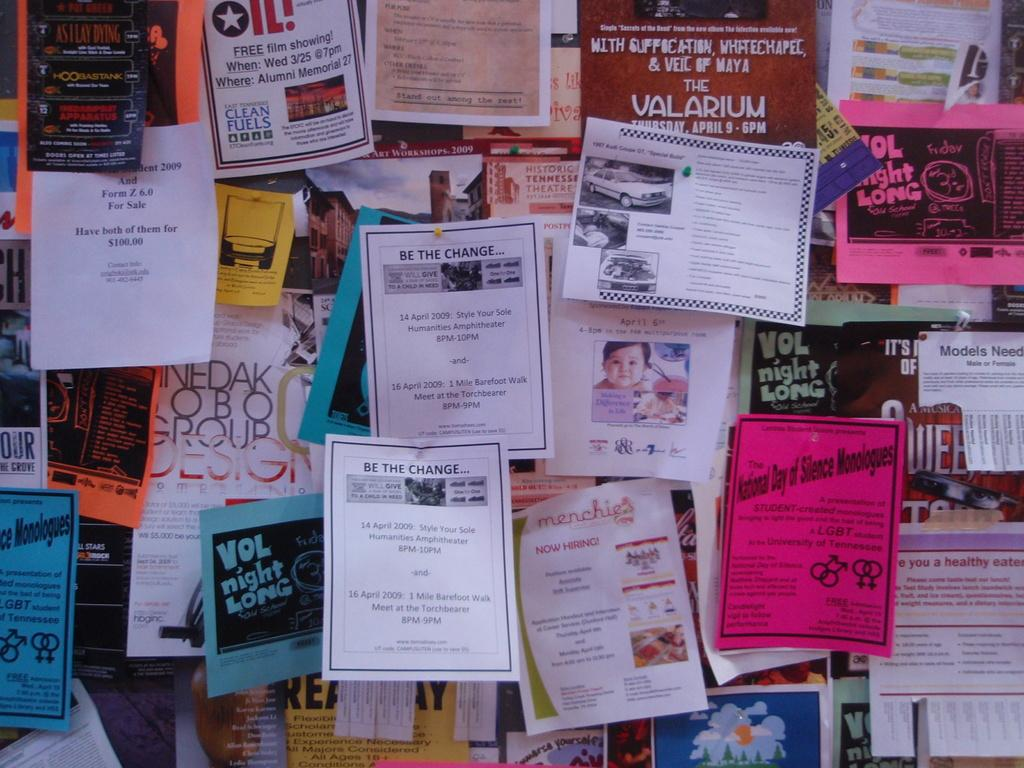<image>
Write a terse but informative summary of the picture. a bulletin board filled with flyers one saying Vol Night Long 